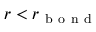<formula> <loc_0><loc_0><loc_500><loc_500>r < r _ { b o n d }</formula> 